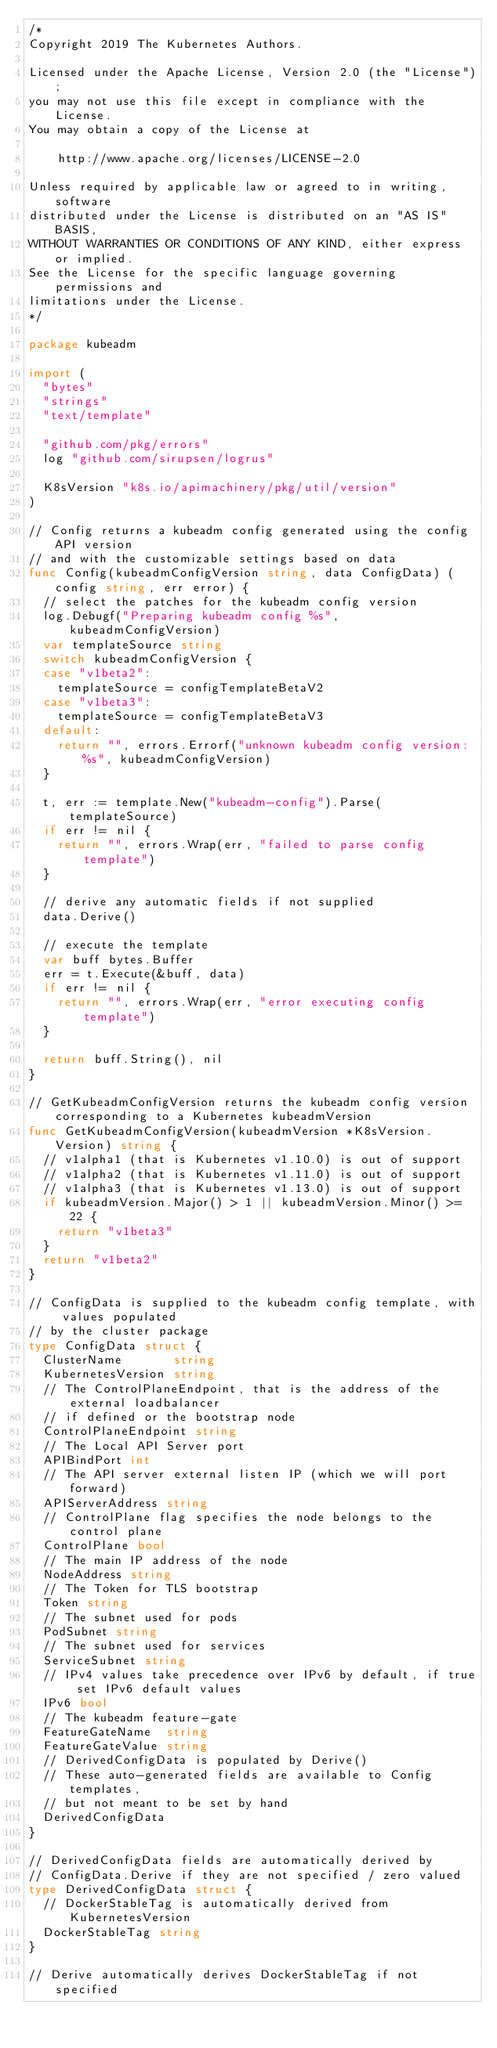<code> <loc_0><loc_0><loc_500><loc_500><_Go_>/*
Copyright 2019 The Kubernetes Authors.

Licensed under the Apache License, Version 2.0 (the "License");
you may not use this file except in compliance with the License.
You may obtain a copy of the License at

    http://www.apache.org/licenses/LICENSE-2.0

Unless required by applicable law or agreed to in writing, software
distributed under the License is distributed on an "AS IS" BASIS,
WITHOUT WARRANTIES OR CONDITIONS OF ANY KIND, either express or implied.
See the License for the specific language governing permissions and
limitations under the License.
*/

package kubeadm

import (
	"bytes"
	"strings"
	"text/template"

	"github.com/pkg/errors"
	log "github.com/sirupsen/logrus"

	K8sVersion "k8s.io/apimachinery/pkg/util/version"
)

// Config returns a kubeadm config generated using the config API version
// and with the customizable settings based on data
func Config(kubeadmConfigVersion string, data ConfigData) (config string, err error) {
	// select the patches for the kubeadm config version
	log.Debugf("Preparing kubeadm config %s", kubeadmConfigVersion)
	var templateSource string
	switch kubeadmConfigVersion {
	case "v1beta2":
		templateSource = configTemplateBetaV2
	case "v1beta3":
		templateSource = configTemplateBetaV3
	default:
		return "", errors.Errorf("unknown kubeadm config version: %s", kubeadmConfigVersion)
	}

	t, err := template.New("kubeadm-config").Parse(templateSource)
	if err != nil {
		return "", errors.Wrap(err, "failed to parse config template")
	}

	// derive any automatic fields if not supplied
	data.Derive()

	// execute the template
	var buff bytes.Buffer
	err = t.Execute(&buff, data)
	if err != nil {
		return "", errors.Wrap(err, "error executing config template")
	}

	return buff.String(), nil
}

// GetKubeadmConfigVersion returns the kubeadm config version corresponding to a Kubernetes kubeadmVersion
func GetKubeadmConfigVersion(kubeadmVersion *K8sVersion.Version) string {
	// v1alpha1 (that is Kubernetes v1.10.0) is out of support
	// v1alpha2 (that is Kubernetes v1.11.0) is out of support
	// v1alpha3 (that is Kubernetes v1.13.0) is out of support
	if kubeadmVersion.Major() > 1 || kubeadmVersion.Minor() >= 22 {
		return "v1beta3"
	}
	return "v1beta2"
}

// ConfigData is supplied to the kubeadm config template, with values populated
// by the cluster package
type ConfigData struct {
	ClusterName       string
	KubernetesVersion string
	// The ControlPlaneEndpoint, that is the address of the external loadbalancer
	// if defined or the bootstrap node
	ControlPlaneEndpoint string
	// The Local API Server port
	APIBindPort int
	// The API server external listen IP (which we will port forward)
	APIServerAddress string
	// ControlPlane flag specifies the node belongs to the control plane
	ControlPlane bool
	// The main IP address of the node
	NodeAddress string
	// The Token for TLS bootstrap
	Token string
	// The subnet used for pods
	PodSubnet string
	// The subnet used for services
	ServiceSubnet string
	// IPv4 values take precedence over IPv6 by default, if true set IPv6 default values
	IPv6 bool
	// The kubeadm feature-gate
	FeatureGateName  string
	FeatureGateValue string
	// DerivedConfigData is populated by Derive()
	// These auto-generated fields are available to Config templates,
	// but not meant to be set by hand
	DerivedConfigData
}

// DerivedConfigData fields are automatically derived by
// ConfigData.Derive if they are not specified / zero valued
type DerivedConfigData struct {
	// DockerStableTag is automatically derived from KubernetesVersion
	DockerStableTag string
}

// Derive automatically derives DockerStableTag if not specified</code> 